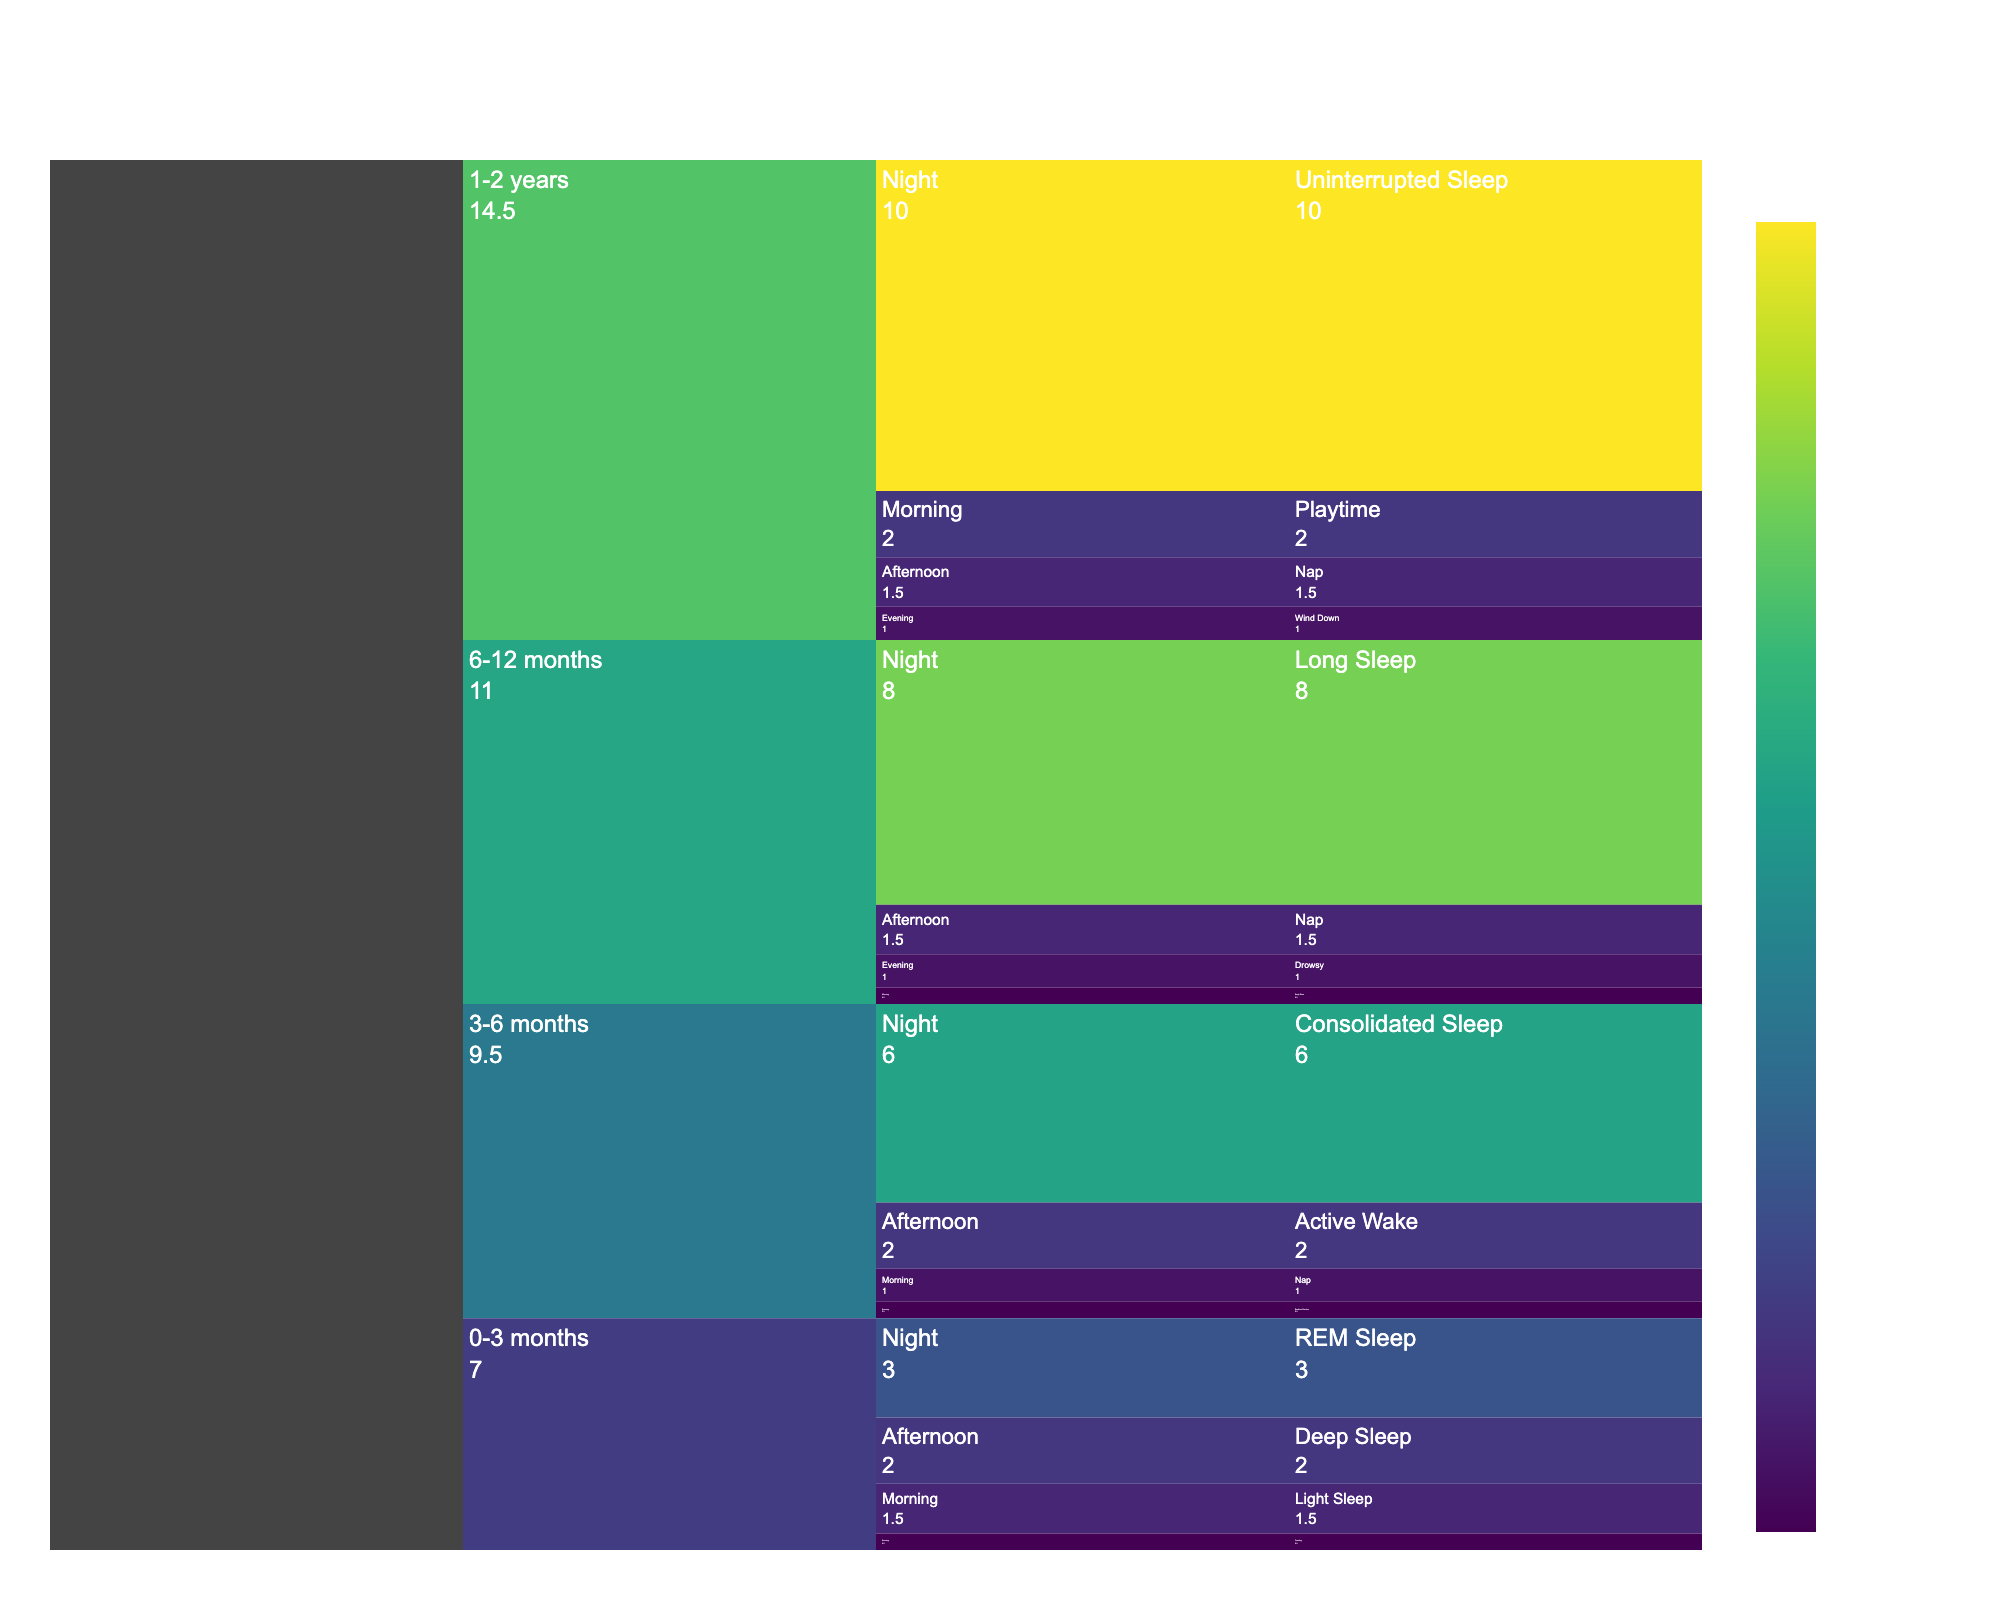What is the title of the figure? The title is usually positioned at the top of the chart and provides a summary of what the chart represents. According to the provided code, the title is set to "Baby Sleep Patterns by Age Group and Time of Day".
Answer: Baby Sleep Patterns by Age Group and Time of Day How many hours of uninterrupted sleep do 1-2-year-olds get at night? To find this, look for the segment related to the "Night" time of day under the age group "1-2 years". The figure should show "Uninterrupted Sleep" with its duration value.
Answer: 10 hours Which age group has the longest sleep duration at night? Compare the duration values for the "Night" sleep patterns across all age groups. The age group "1-2 years" has "Uninterrupted Sleep" lasting 10 hours, which is the longest compared to the other age groups.
Answer: 1-2 years What is the total duration of sleep patterns for the 0-3 months age group? Sum up all the sleep pattern durations for the 0-3 months age group: Light Sleep (1.5), Deep Sleep (2), Feeding (0.5), REM Sleep (3). The total is 1.5 + 2 + 0.5 + 3 = 7.0 hours.
Answer: 7.0 hours Which time of day do 6-12 months old babies have the longest sleep? Within the 6-12 months age group, look at the durations for each time of day. "Night" has the longest duration with "Long Sleep" at 8 hours.
Answer: Night What sleep pattern is observed in the afternoon for 3-6 months old babies, and how long does it last? Find the afternoon segment under the 3-6 months age group, where the sleep pattern "Active Wake" is shown with a duration of 2 hours.
Answer: Active Wake, 2 hours How does the duration of consolidated sleep for 3-6 months old compare to the long sleep for 6-12 months old? The duration of consolidated sleep for 3-6 months is 6 hours, while the long sleep for 6-12 months is 8 hours. Comparing these, 6 hours is shorter than 8 hours.
Answer: Shorter How many distinct sleep patterns are shown for the 1-2 years age group? Count the unique sleep patterns listed under the 1-2 years age group. They are "Playtime", "Nap", "Wind Down", and "Uninterrupted Sleep", making a total of 4 distinct patterns.
Answer: 4 What is the average sleep duration at night across all age groups? Summing the durations for night sleep patterns (0-3 months: 3, 3-6 months: 6, 6-12 months: 8, 1-2 years: 10) gives 27. The average is 27 divided by the 4 age groups: 27 / 4 = 6.75 hours.
Answer: 6.75 hours How much more sleep do 6-12 months old babies get at night compared to 3-6 months old babies? The night sleep duration for 6-12 months is 8 hours, and for 3-6 months, it is 6 hours. The difference is 8 - 6 = 2 hours.
Answer: 2 hours 